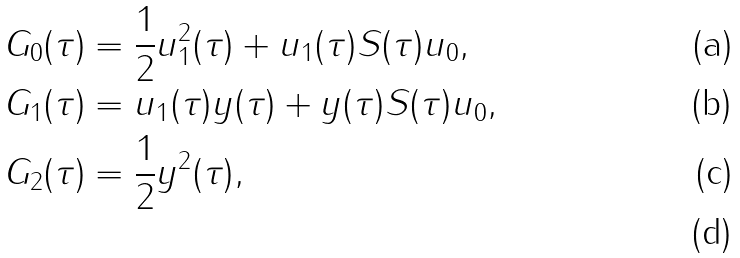<formula> <loc_0><loc_0><loc_500><loc_500>& G _ { 0 } ( \tau ) = \frac { 1 } { 2 } u _ { 1 } ^ { 2 } ( \tau ) + u _ { 1 } ( \tau ) S ( \tau ) u _ { 0 } , \\ & G _ { 1 } ( \tau ) = u _ { 1 } ( \tau ) y ( \tau ) + y ( \tau ) S ( \tau ) u _ { 0 } , \\ & G _ { 2 } ( \tau ) = \frac { 1 } { 2 } y ^ { 2 } ( \tau ) , \\</formula> 